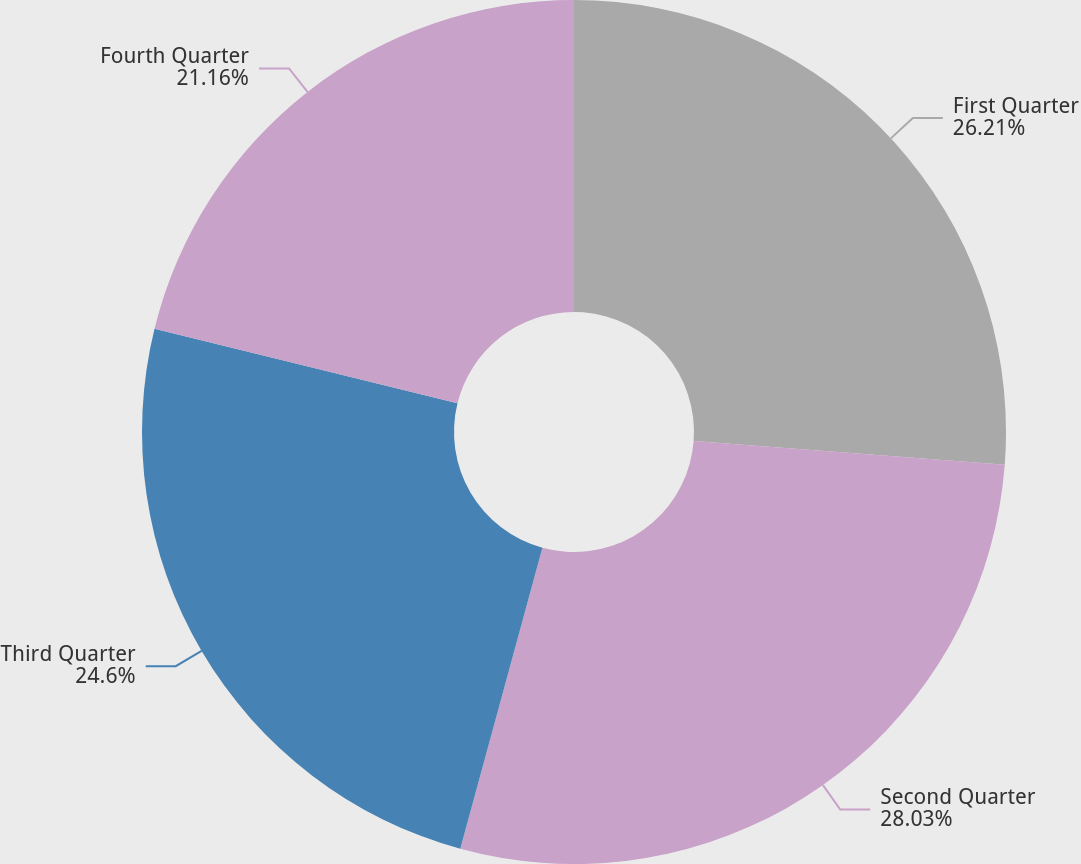Convert chart. <chart><loc_0><loc_0><loc_500><loc_500><pie_chart><fcel>First Quarter<fcel>Second Quarter<fcel>Third Quarter<fcel>Fourth Quarter<nl><fcel>26.21%<fcel>28.03%<fcel>24.6%<fcel>21.16%<nl></chart> 